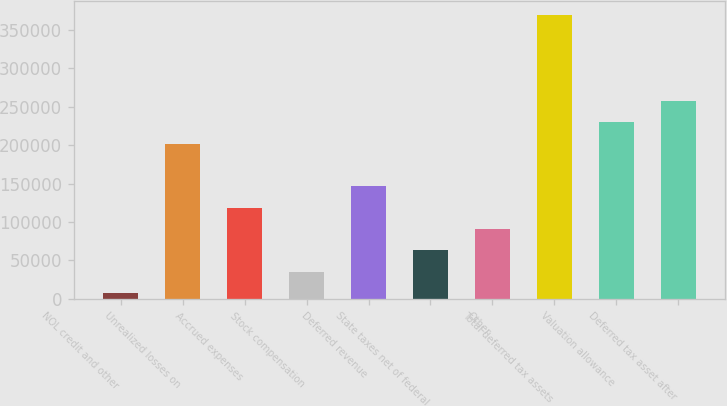<chart> <loc_0><loc_0><loc_500><loc_500><bar_chart><fcel>NOL credit and other<fcel>Unrealized losses on<fcel>Accrued expenses<fcel>Stock compensation<fcel>Deferred revenue<fcel>State taxes net of federal<fcel>Other<fcel>Total deferred tax assets<fcel>Valuation allowance<fcel>Deferred tax asset after<nl><fcel>7682<fcel>202029<fcel>118738<fcel>35445.9<fcel>146502<fcel>63209.8<fcel>90973.7<fcel>368613<fcel>229793<fcel>257557<nl></chart> 